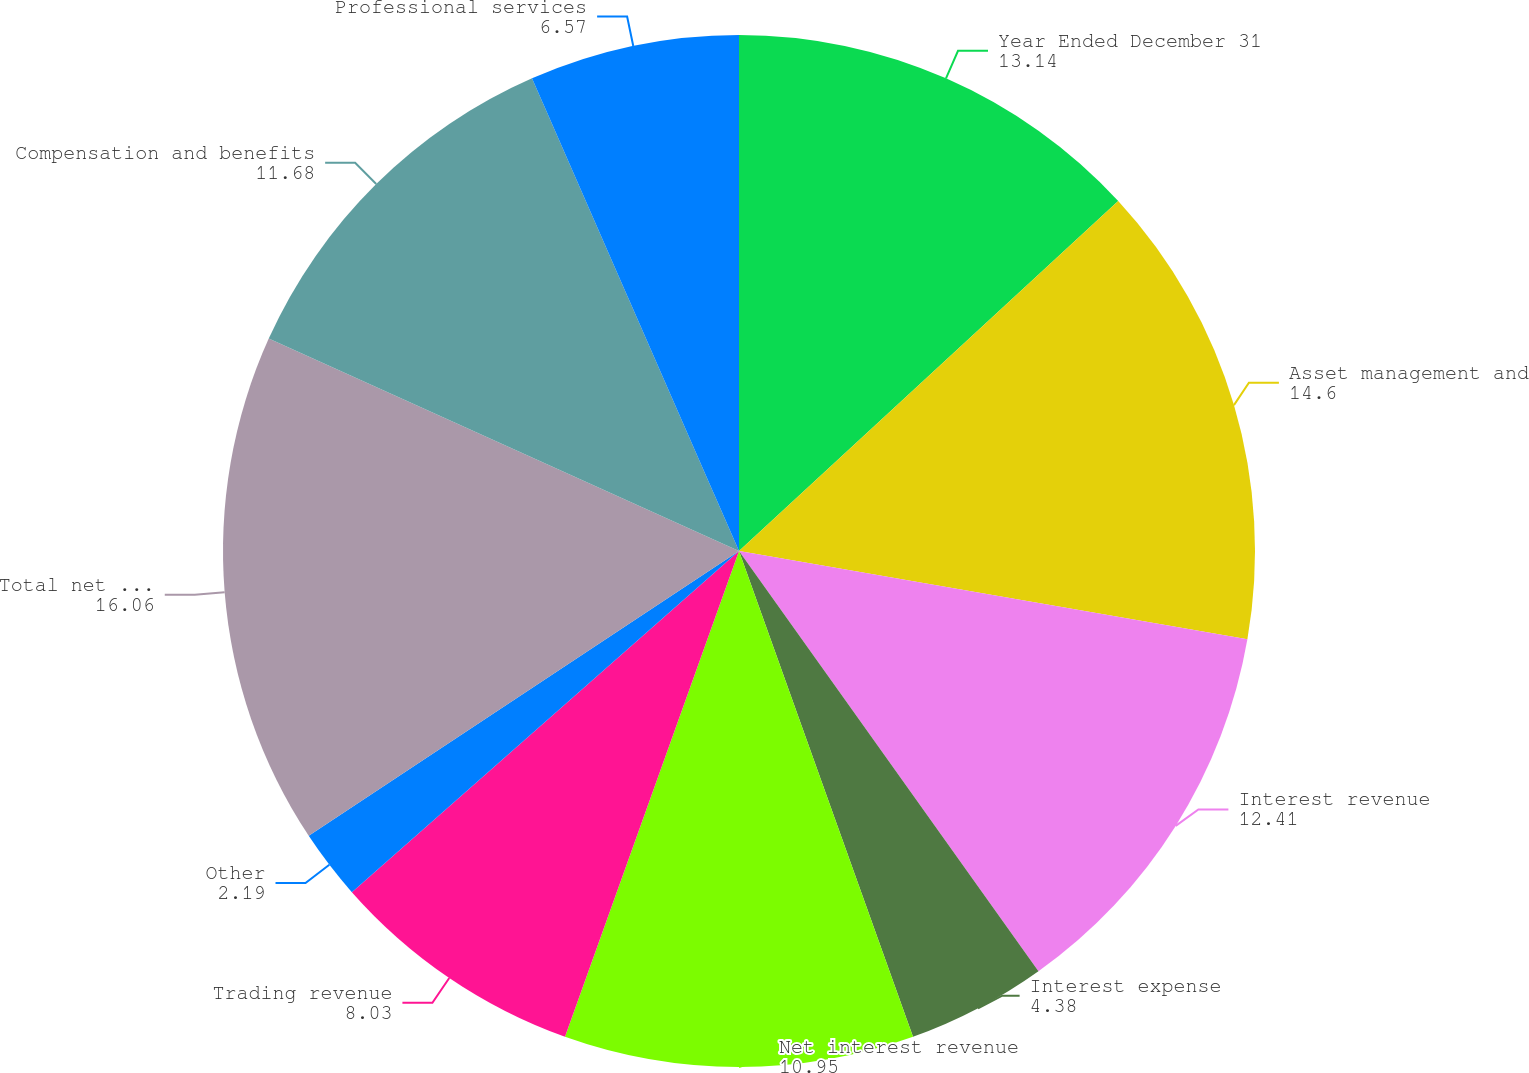Convert chart to OTSL. <chart><loc_0><loc_0><loc_500><loc_500><pie_chart><fcel>Year Ended December 31<fcel>Asset management and<fcel>Interest revenue<fcel>Interest expense<fcel>Net interest revenue<fcel>Trading revenue<fcel>Other<fcel>Total net revenues<fcel>Compensation and benefits<fcel>Professional services<nl><fcel>13.14%<fcel>14.6%<fcel>12.41%<fcel>4.38%<fcel>10.95%<fcel>8.03%<fcel>2.19%<fcel>16.06%<fcel>11.68%<fcel>6.57%<nl></chart> 